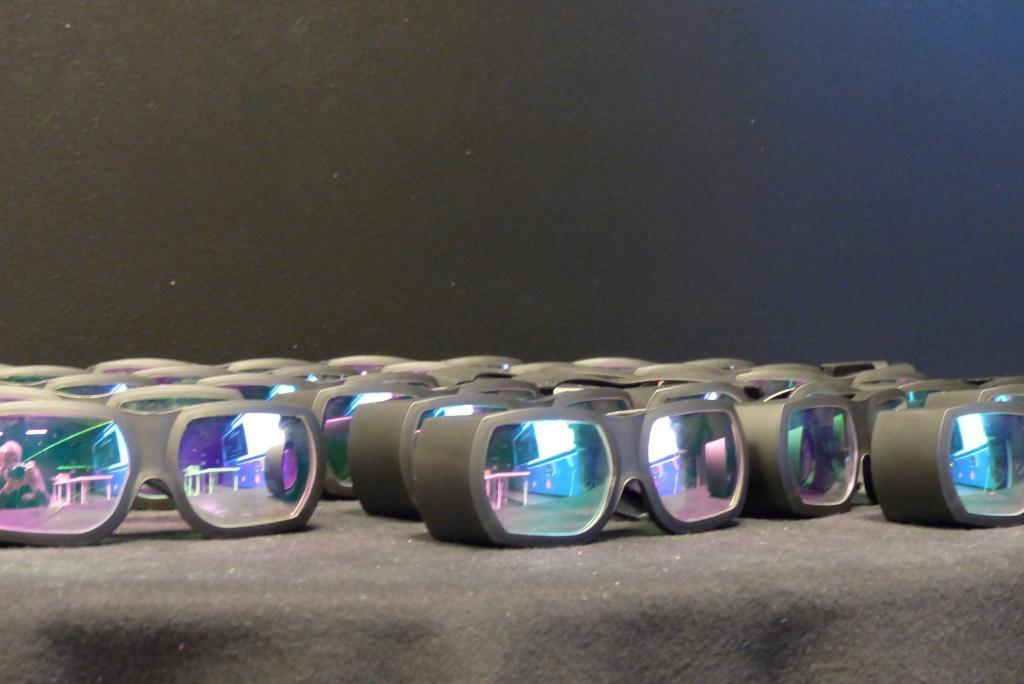What is placed on the platform in the image? There are goggles on a platform in the image. Can you describe the background of the image? The background of the image is dark. What type of pets are visible in the image? There are no pets visible in the image; it only features goggles on a platform and a dark background. 